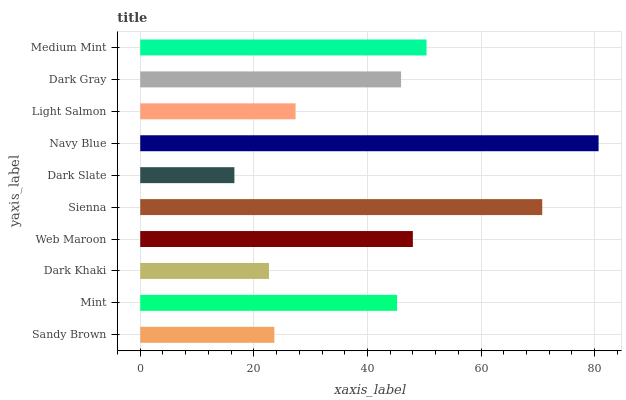Is Dark Slate the minimum?
Answer yes or no. Yes. Is Navy Blue the maximum?
Answer yes or no. Yes. Is Mint the minimum?
Answer yes or no. No. Is Mint the maximum?
Answer yes or no. No. Is Mint greater than Sandy Brown?
Answer yes or no. Yes. Is Sandy Brown less than Mint?
Answer yes or no. Yes. Is Sandy Brown greater than Mint?
Answer yes or no. No. Is Mint less than Sandy Brown?
Answer yes or no. No. Is Dark Gray the high median?
Answer yes or no. Yes. Is Mint the low median?
Answer yes or no. Yes. Is Sienna the high median?
Answer yes or no. No. Is Dark Khaki the low median?
Answer yes or no. No. 